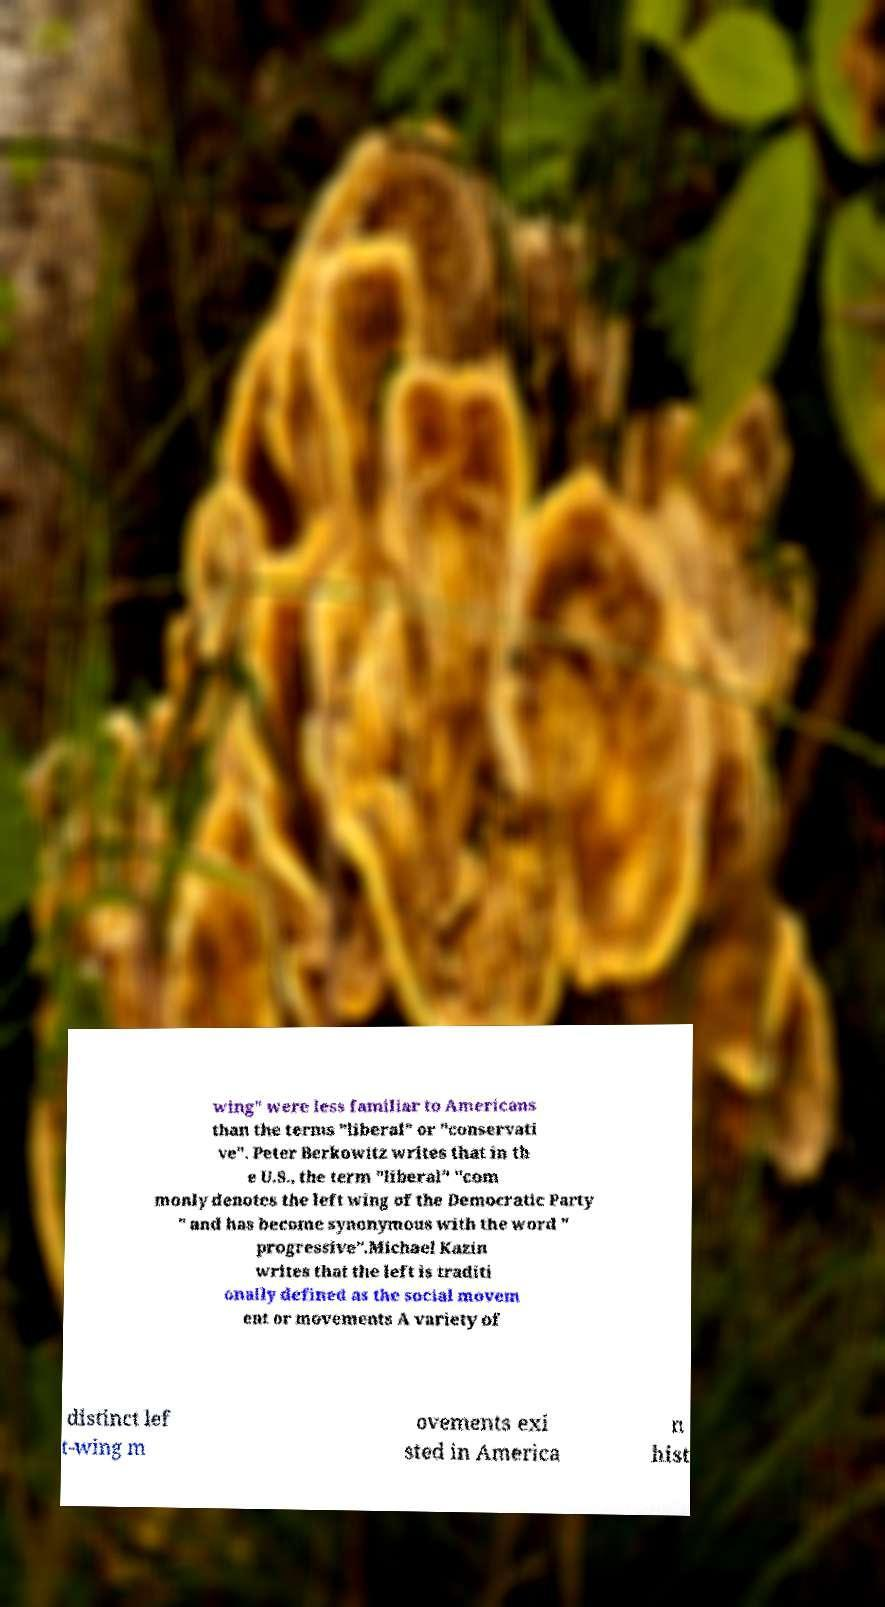Please identify and transcribe the text found in this image. wing" were less familiar to Americans than the terms "liberal" or "conservati ve". Peter Berkowitz writes that in th e U.S., the term "liberal" "com monly denotes the left wing of the Democratic Party " and has become synonymous with the word " progressive".Michael Kazin writes that the left is traditi onally defined as the social movem ent or movements A variety of distinct lef t-wing m ovements exi sted in America n hist 